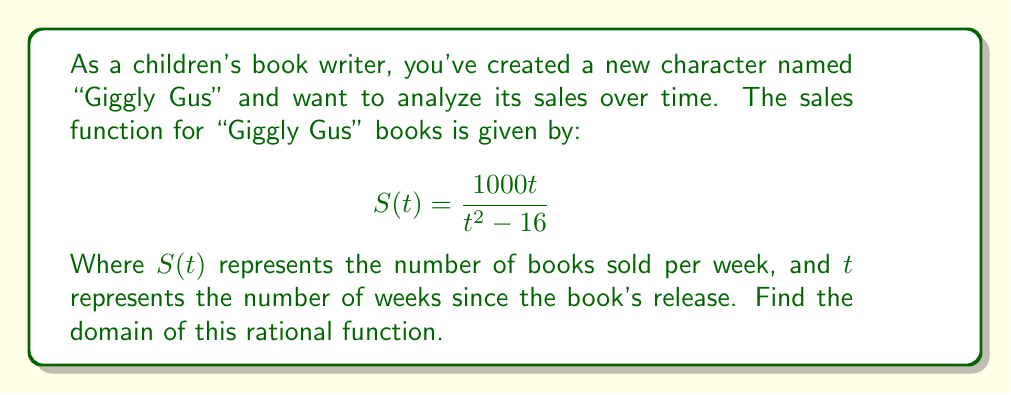What is the answer to this math problem? To find the domain of this rational function, we need to consider where the function is defined. A rational function is undefined when its denominator equals zero.

Step 1: Set the denominator equal to zero and solve for t.
$$t^2 - 16 = 0$$
$$t^2 = 16$$
$$t = \pm 4$$

Step 2: The function will be undefined when $t = 4$ or $t = -4$. However, since time cannot be negative in this context, we only need to consider $t = 4$ as a restriction.

Step 3: The domain will be all real numbers except for the value that makes the denominator zero. In this case, it's all real numbers greater than or equal to 0 (since time can't be negative), except for 4.

We can express this in interval notation as:
$$[0, 4) \cup (4, \infty)$$

This means the function is defined from 0 to 4 (not including 4) and from 4 to infinity (not including 4).
Answer: $[0, 4) \cup (4, \infty)$ 